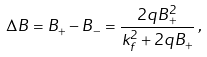<formula> <loc_0><loc_0><loc_500><loc_500>\Delta B = B _ { + } - B _ { - } = \frac { 2 q B _ { + } ^ { 2 } } { k _ { f } ^ { 2 } + 2 q B _ { + } } \, ,</formula> 